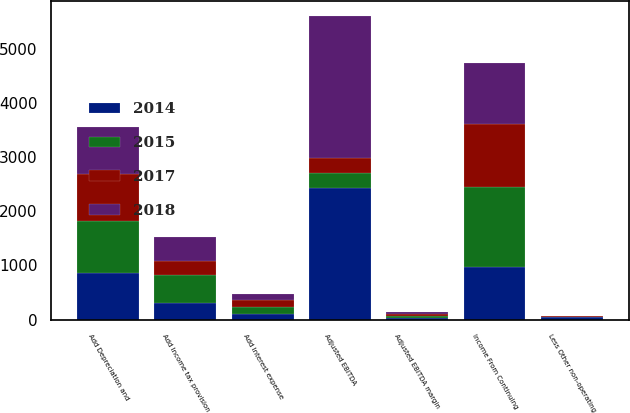Convert chart. <chart><loc_0><loc_0><loc_500><loc_500><stacked_bar_chart><ecel><fcel>Income From Continuing<fcel>Add Interest expense<fcel>Less Other non-operating<fcel>Add Income tax provision<fcel>Add Depreciation and<fcel>Adjusted EBITDA<fcel>Adjusted EBITDA margin<nl><fcel>2015<fcel>1490.7<fcel>130.5<fcel>5.1<fcel>524.3<fcel>970.7<fcel>280.55<fcel>34.9<nl><fcel>2017<fcel>1155.2<fcel>120.6<fcel>16.6<fcel>260.9<fcel>865.8<fcel>280.55<fcel>34.2<nl><fcel>2018<fcel>1122<fcel>115.2<fcel>5.4<fcel>432.6<fcel>854.6<fcel>2621.8<fcel>34.9<nl><fcel>2014<fcel>965.9<fcel>102.8<fcel>42.3<fcel>300.2<fcel>858.5<fcel>2422.4<fcel>31<nl></chart> 